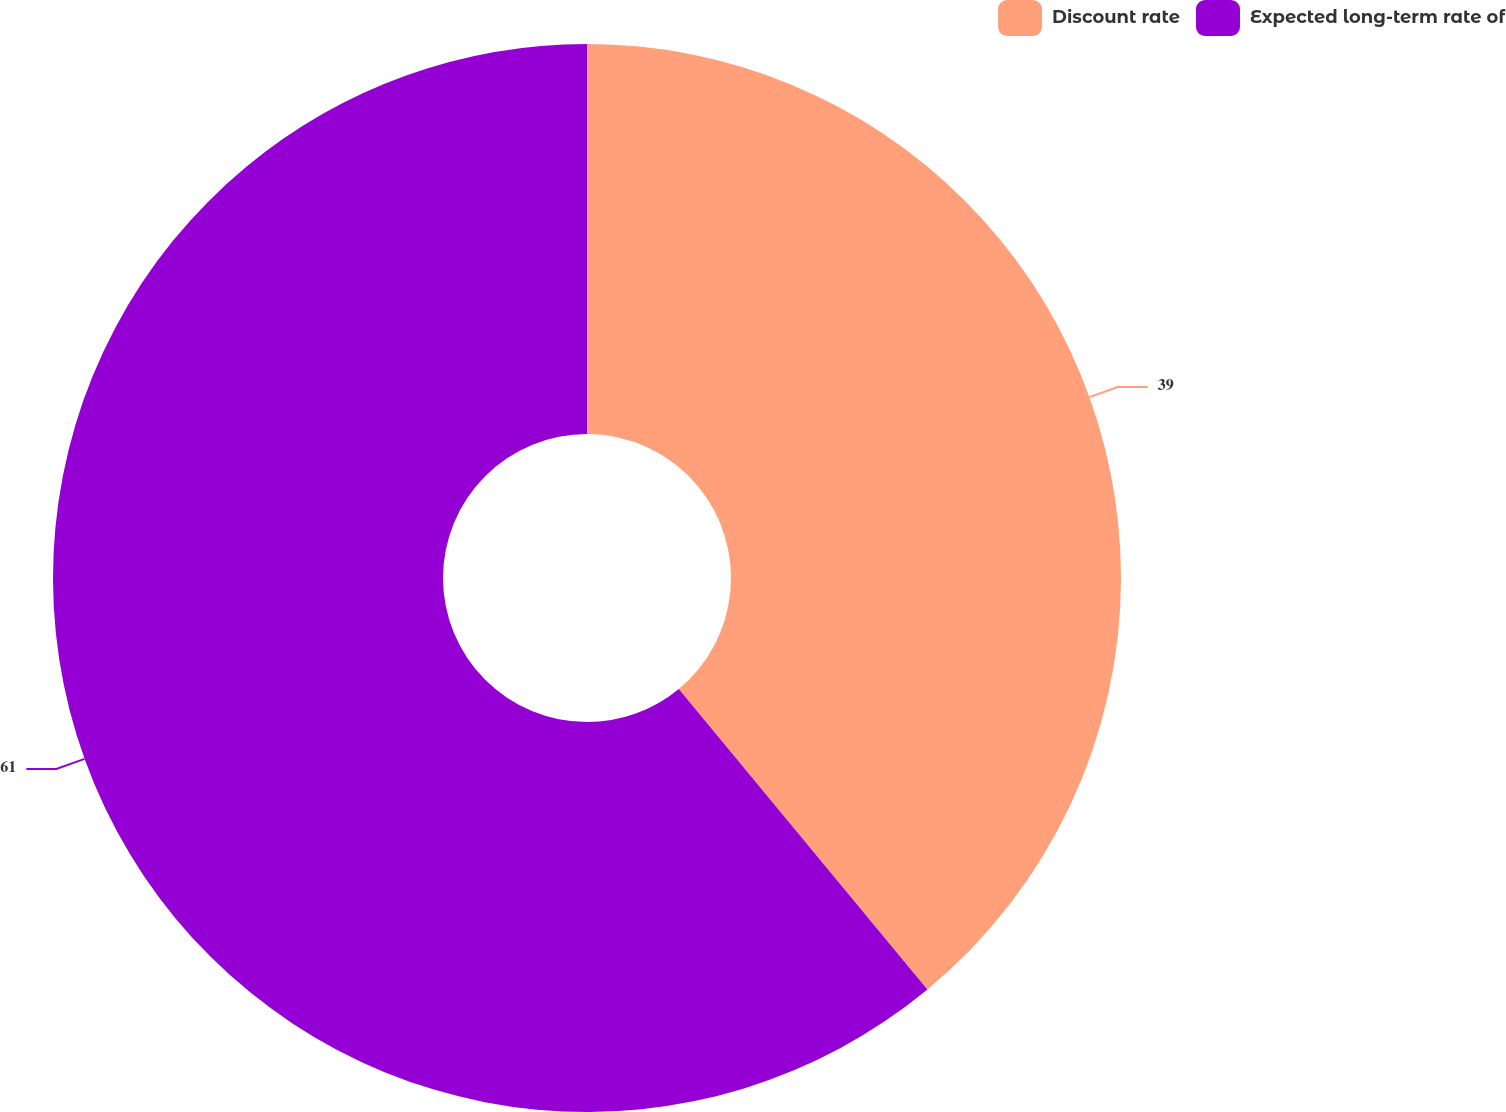<chart> <loc_0><loc_0><loc_500><loc_500><pie_chart><fcel>Discount rate<fcel>Expected long-term rate of<nl><fcel>39.0%<fcel>61.0%<nl></chart> 